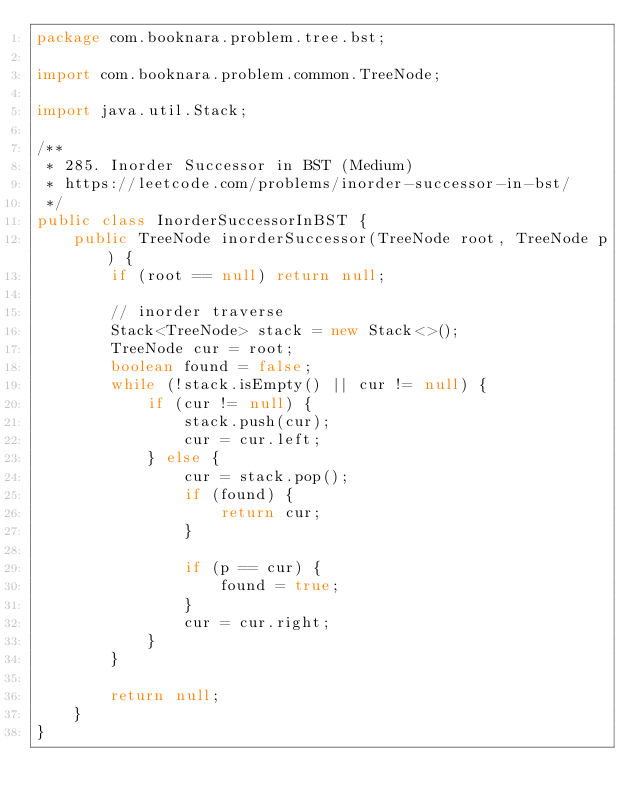Convert code to text. <code><loc_0><loc_0><loc_500><loc_500><_Java_>package com.booknara.problem.tree.bst;

import com.booknara.problem.common.TreeNode;

import java.util.Stack;

/**
 * 285. Inorder Successor in BST (Medium)
 * https://leetcode.com/problems/inorder-successor-in-bst/
 */
public class InorderSuccessorInBST {
    public TreeNode inorderSuccessor(TreeNode root, TreeNode p) {
        if (root == null) return null;

        // inorder traverse
        Stack<TreeNode> stack = new Stack<>();
        TreeNode cur = root;
        boolean found = false;
        while (!stack.isEmpty() || cur != null) {
            if (cur != null) {
                stack.push(cur);
                cur = cur.left;
            } else {
                cur = stack.pop();
                if (found) {
                    return cur;
                }

                if (p == cur) {
                    found = true;
                }
                cur = cur.right;
            }
        }

        return null;
    }
}
</code> 